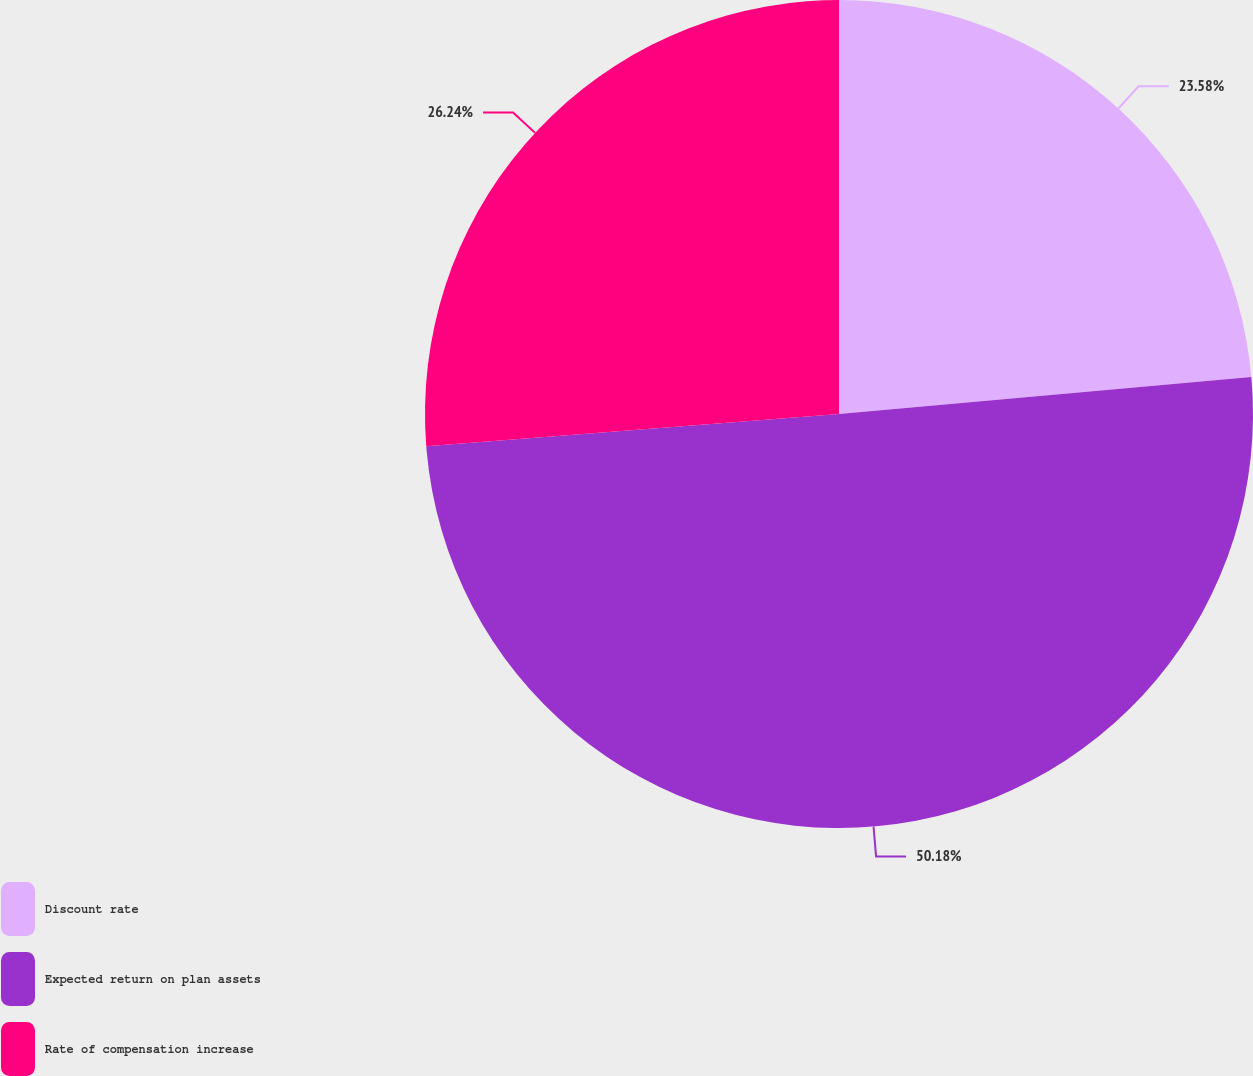<chart> <loc_0><loc_0><loc_500><loc_500><pie_chart><fcel>Discount rate<fcel>Expected return on plan assets<fcel>Rate of compensation increase<nl><fcel>23.58%<fcel>50.18%<fcel>26.24%<nl></chart> 